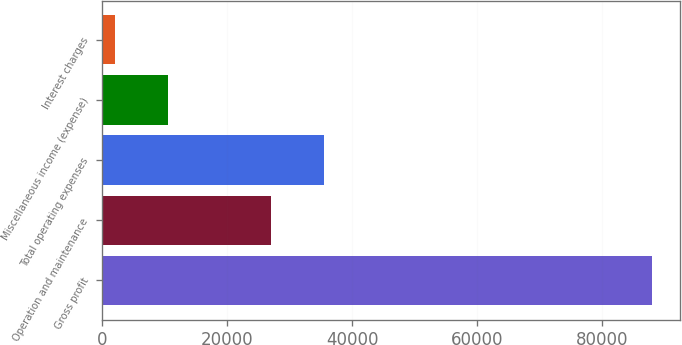Convert chart. <chart><loc_0><loc_0><loc_500><loc_500><bar_chart><fcel>Gross profit<fcel>Operation and maintenance<fcel>Total operating expenses<fcel>Miscellaneous income (expense)<fcel>Interest charges<nl><fcel>87955<fcel>26963<fcel>35559.9<fcel>10582.9<fcel>1986<nl></chart> 